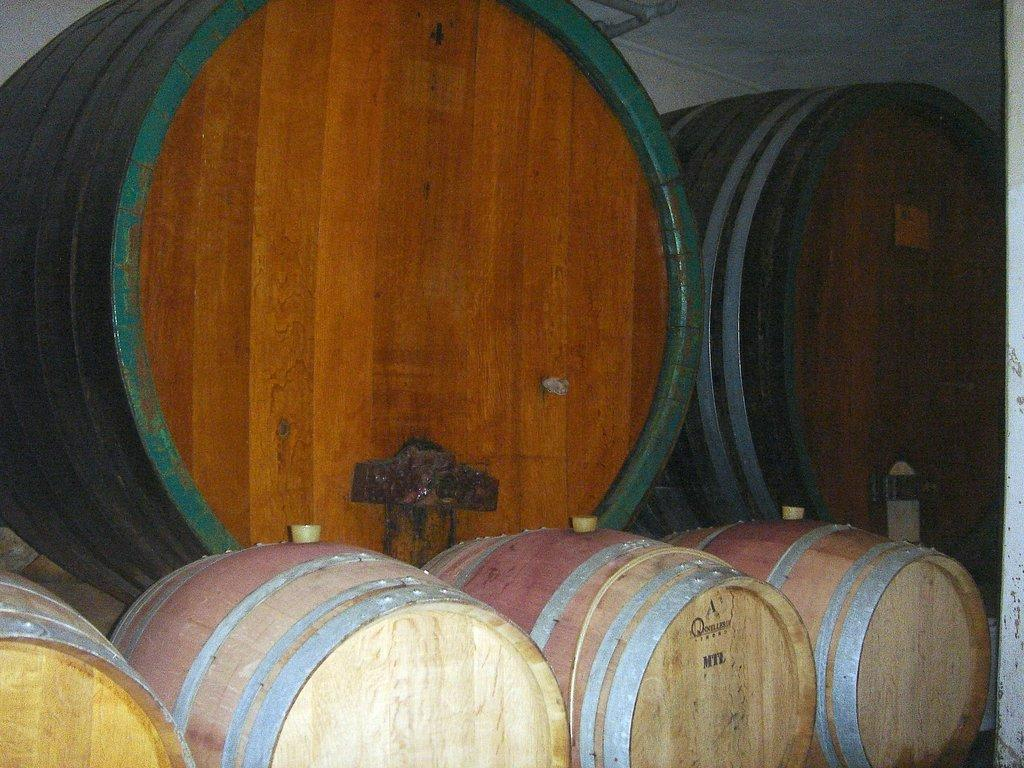What objects are located in the center of the image? There are barrels in the center of the image. What can be seen in the background of the image? There is a wall in the background of the image. What type of mask is being worn by the barrels in the image? There are no masks present in the image, as the main subjects are barrels. 